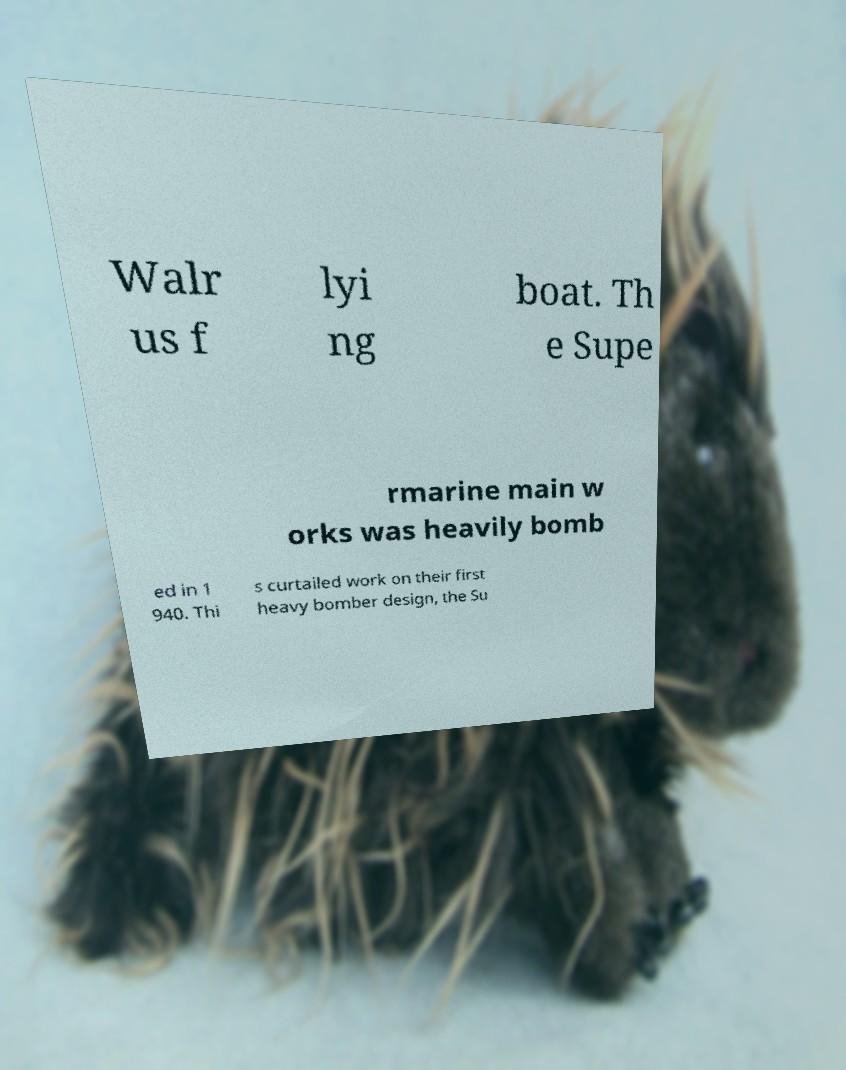Can you read and provide the text displayed in the image?This photo seems to have some interesting text. Can you extract and type it out for me? Walr us f lyi ng boat. Th e Supe rmarine main w orks was heavily bomb ed in 1 940. Thi s curtailed work on their first heavy bomber design, the Su 